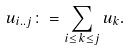<formula> <loc_0><loc_0><loc_500><loc_500>u _ { i . . j } \colon = \sum _ { i \leq k \leq j } u _ { k } .</formula> 